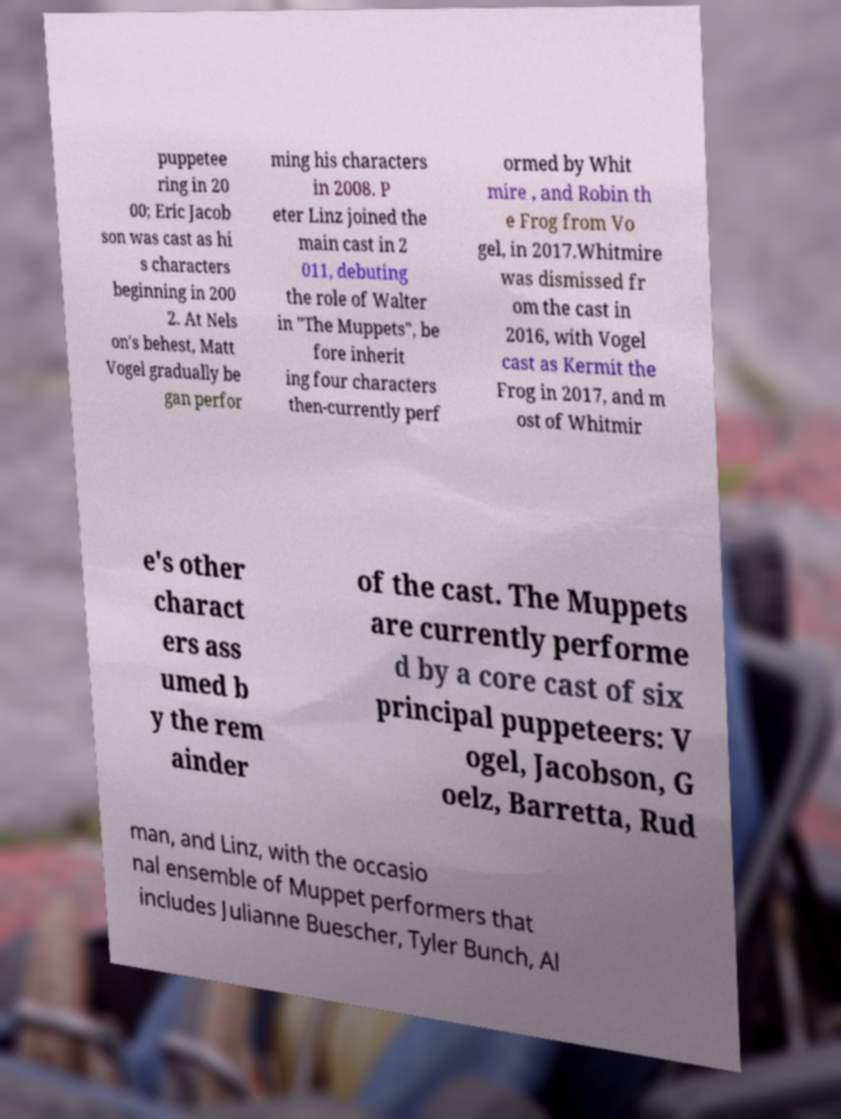Can you accurately transcribe the text from the provided image for me? puppetee ring in 20 00; Eric Jacob son was cast as hi s characters beginning in 200 2. At Nels on's behest, Matt Vogel gradually be gan perfor ming his characters in 2008. P eter Linz joined the main cast in 2 011, debuting the role of Walter in "The Muppets", be fore inherit ing four characters then-currently perf ormed by Whit mire , and Robin th e Frog from Vo gel, in 2017.Whitmire was dismissed fr om the cast in 2016, with Vogel cast as Kermit the Frog in 2017, and m ost of Whitmir e's other charact ers ass umed b y the rem ainder of the cast. The Muppets are currently performe d by a core cast of six principal puppeteers: V ogel, Jacobson, G oelz, Barretta, Rud man, and Linz, with the occasio nal ensemble of Muppet performers that includes Julianne Buescher, Tyler Bunch, Al 